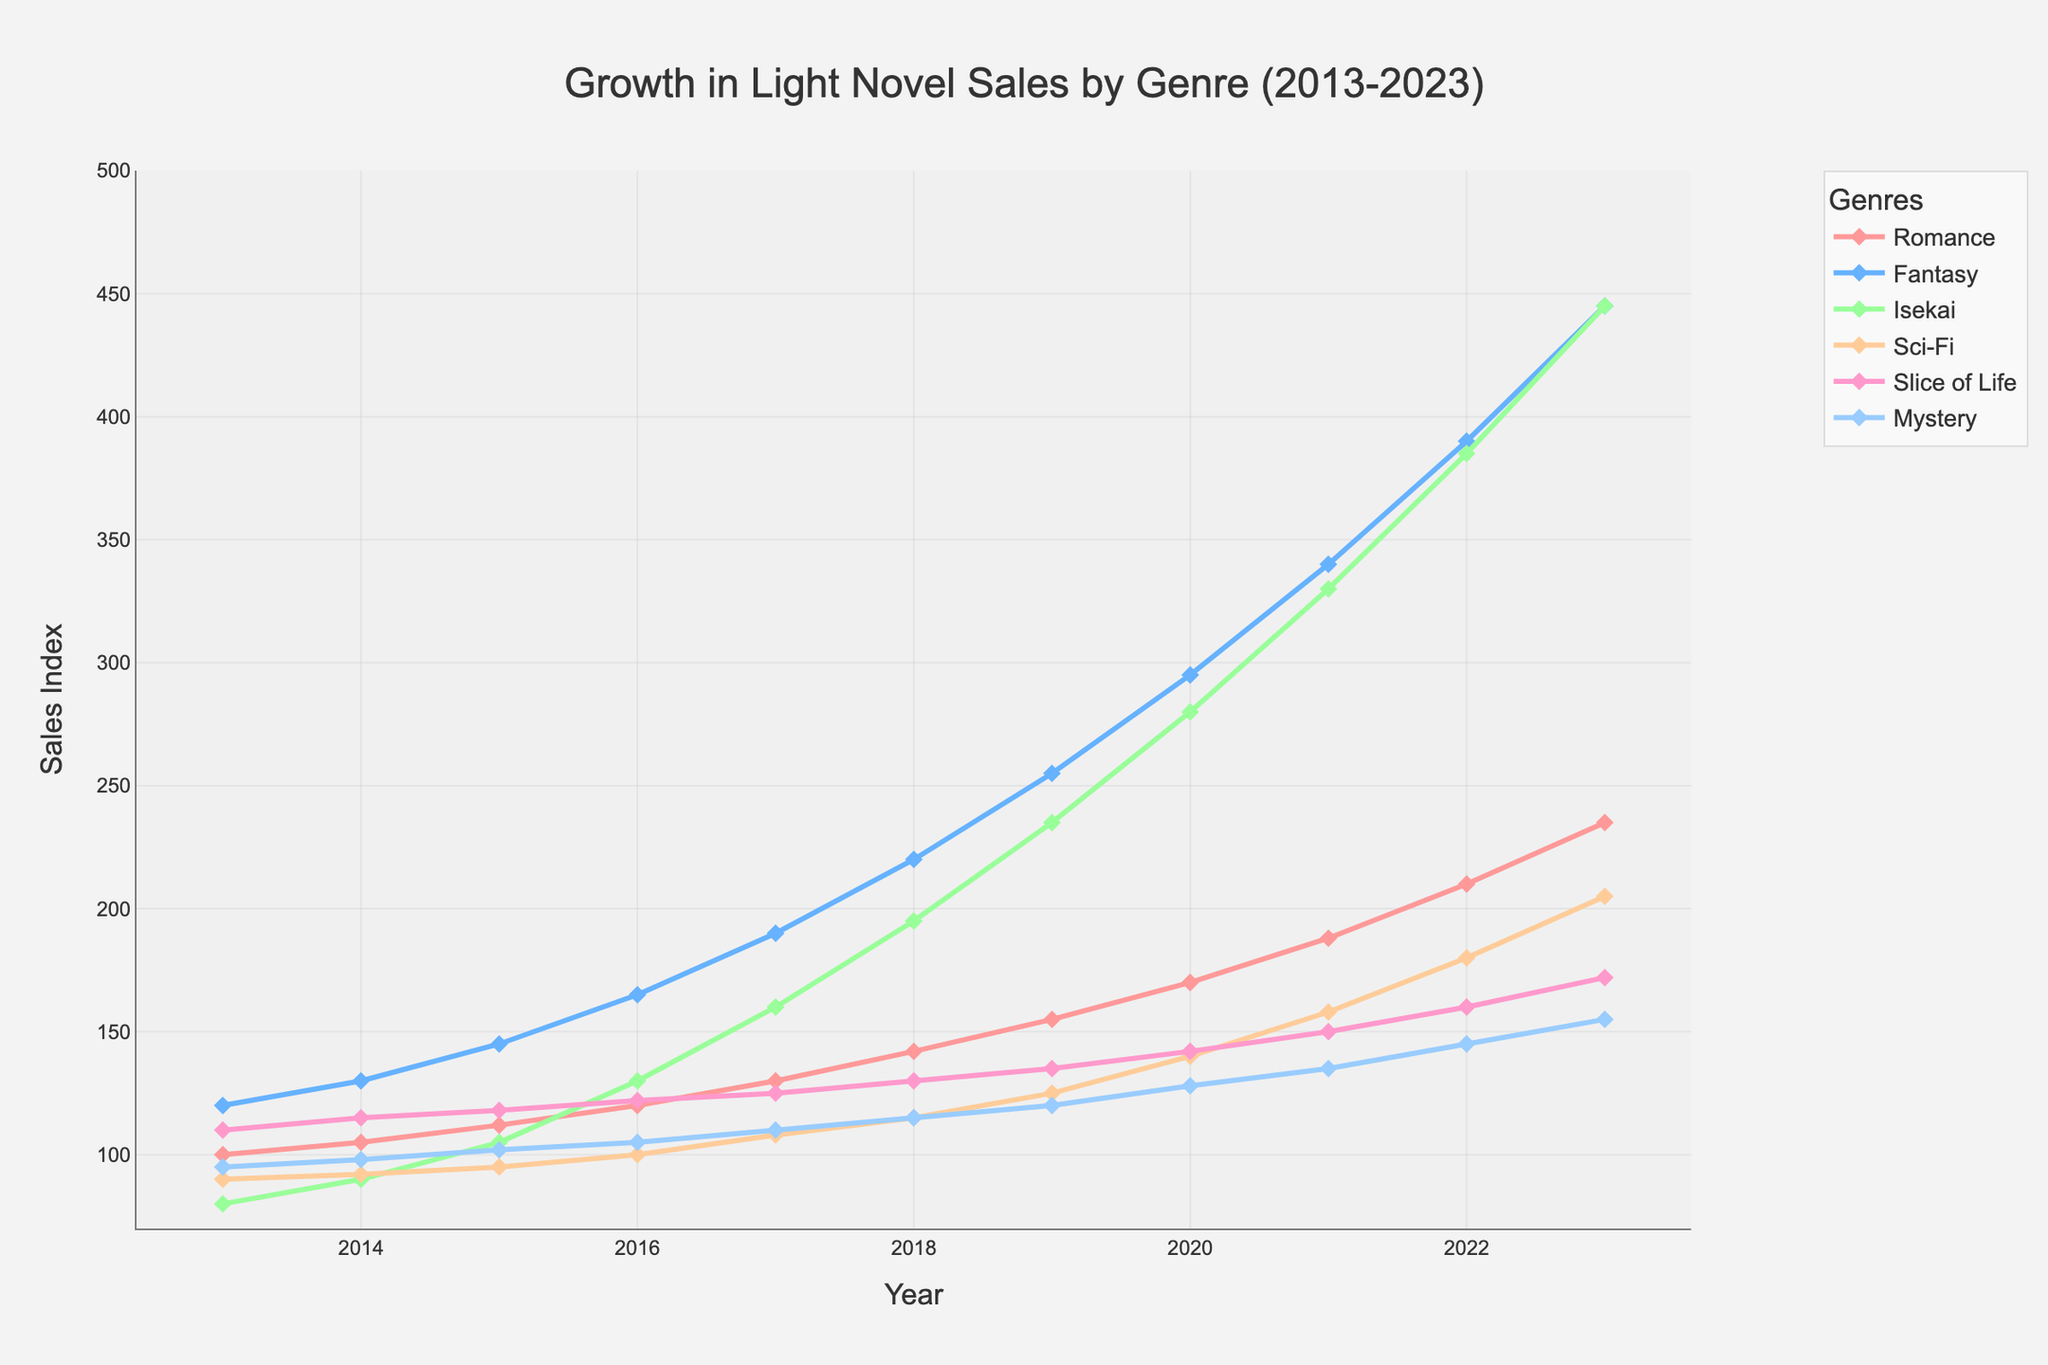What genre had the highest sales in 2023? Look at the points for each genre in 2023 and compare their heights. The highest point in 2023 belongs to the Fantasy genre.
Answer: Fantasy Which year did the Isekai genre first surpass 200 in sales? Look at the Isekai line and find the point where it intersects the 200 sales mark for the first time. This happens in 2018.
Answer: 2018 How much did Romance sales increase from 2013 to 2023? Subtract the Romance sales in 2013 from the Romance sales in 2023: 235 - 100 = 135.
Answer: 135 Which genre had the smallest increase in sales from 2013 to 2023? Calculate the increase for each genre by subtracting the 2013 value from the 2023 value and compare. The genre with the smallest increase is Mystery (155 - 95 = 60).
Answer: Mystery Between which consecutive years did the Slice of Life genre show the most significant growth? Calculate the year-over-year change for Slice of Life and find the maximum difference. The most substantial increase is from 2022 to 2023 (172 - 160 = 12).
Answer: 2022 to 2023 Did any genre's sales decline between any consecutive years? If so, which year and genre? Examine the lines for any downward trends between consecutive years. The Sci-Fi genre experienced a decline from 2016 to 2017 (100 to 108).
Answer: No What is the average sales of the Fantasy genre over the decade? Sum the Fantasy sales from 2013 to 2023 and divide by 11: (120 + 130 + 145 + 165 + 190 + 220 + 255 + 295 + 340 + 390 + 445) / 11 ≈ 245.
Answer: 245 How did the Mystery genre sales in 2023 compare to the Romance genre sales in 2023? Compare the sales index of the Mystery genre (155) and the Romance genre (235) in 2023. The Romance genre sales were higher.
Answer: Romance was higher Which genre had a continuous increase in sales every year over the decade? Check each genre's line for any dips. The Isekai genre shows a continuous rise without any decreases.
Answer: Isekai By how much did the sales of Sci-Fi increase from 2019 to 2020? Subtract the 2019 sales of Sci-Fi from the 2020 sales: 140 - 125 = 15.
Answer: 15 